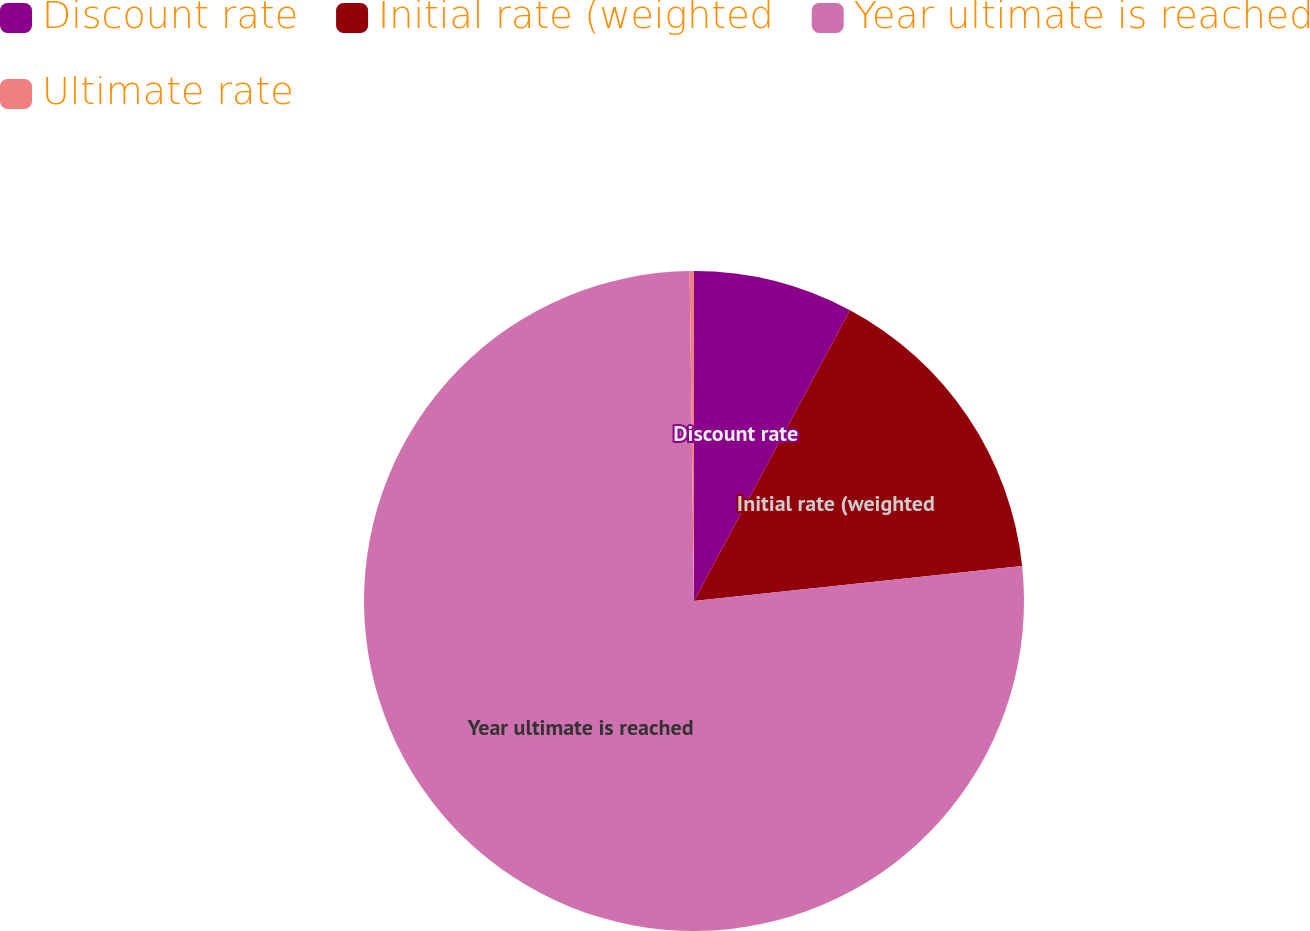Convert chart. <chart><loc_0><loc_0><loc_500><loc_500><pie_chart><fcel>Discount rate<fcel>Initial rate (weighted<fcel>Year ultimate is reached<fcel>Ultimate rate<nl><fcel>7.84%<fcel>15.47%<fcel>76.49%<fcel>0.21%<nl></chart> 